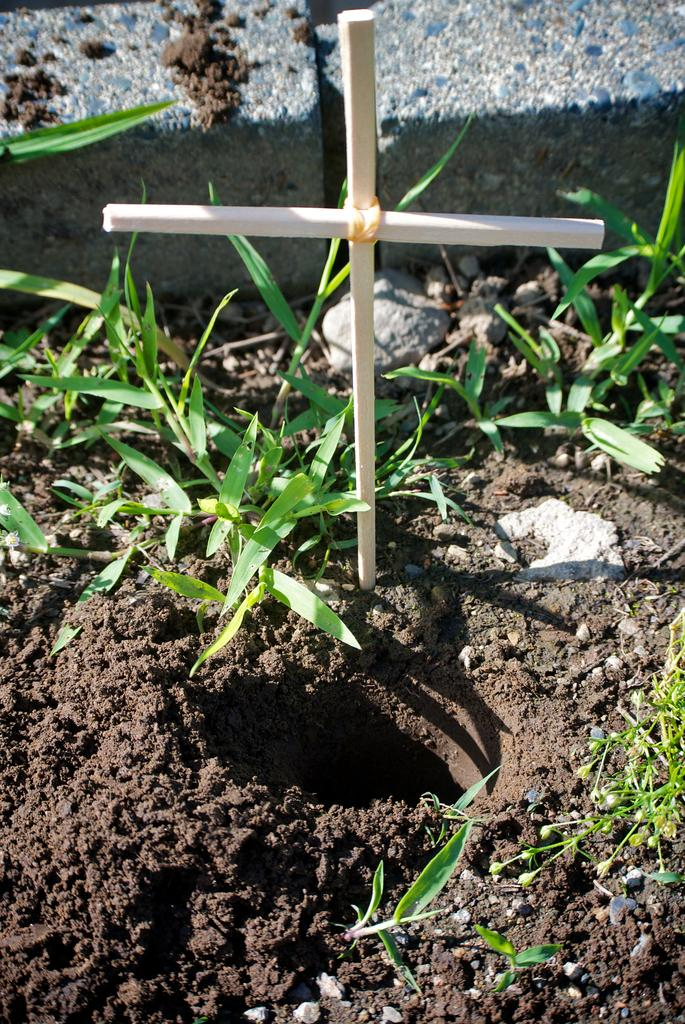What type of natural elements can be seen in the image? There are stones, soil, and grass in the image. What additional feature is present in the image? There is a cross symbol in the image. What type of stage can be seen in the image? There is no stage present in the image. What type of humor is depicted in the image? There is no humor depicted in the image. 